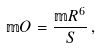<formula> <loc_0><loc_0><loc_500><loc_500>\mathbb { m } { O } = \frac { \mathbb { m } { R } ^ { 6 } } { S } \, ,</formula> 